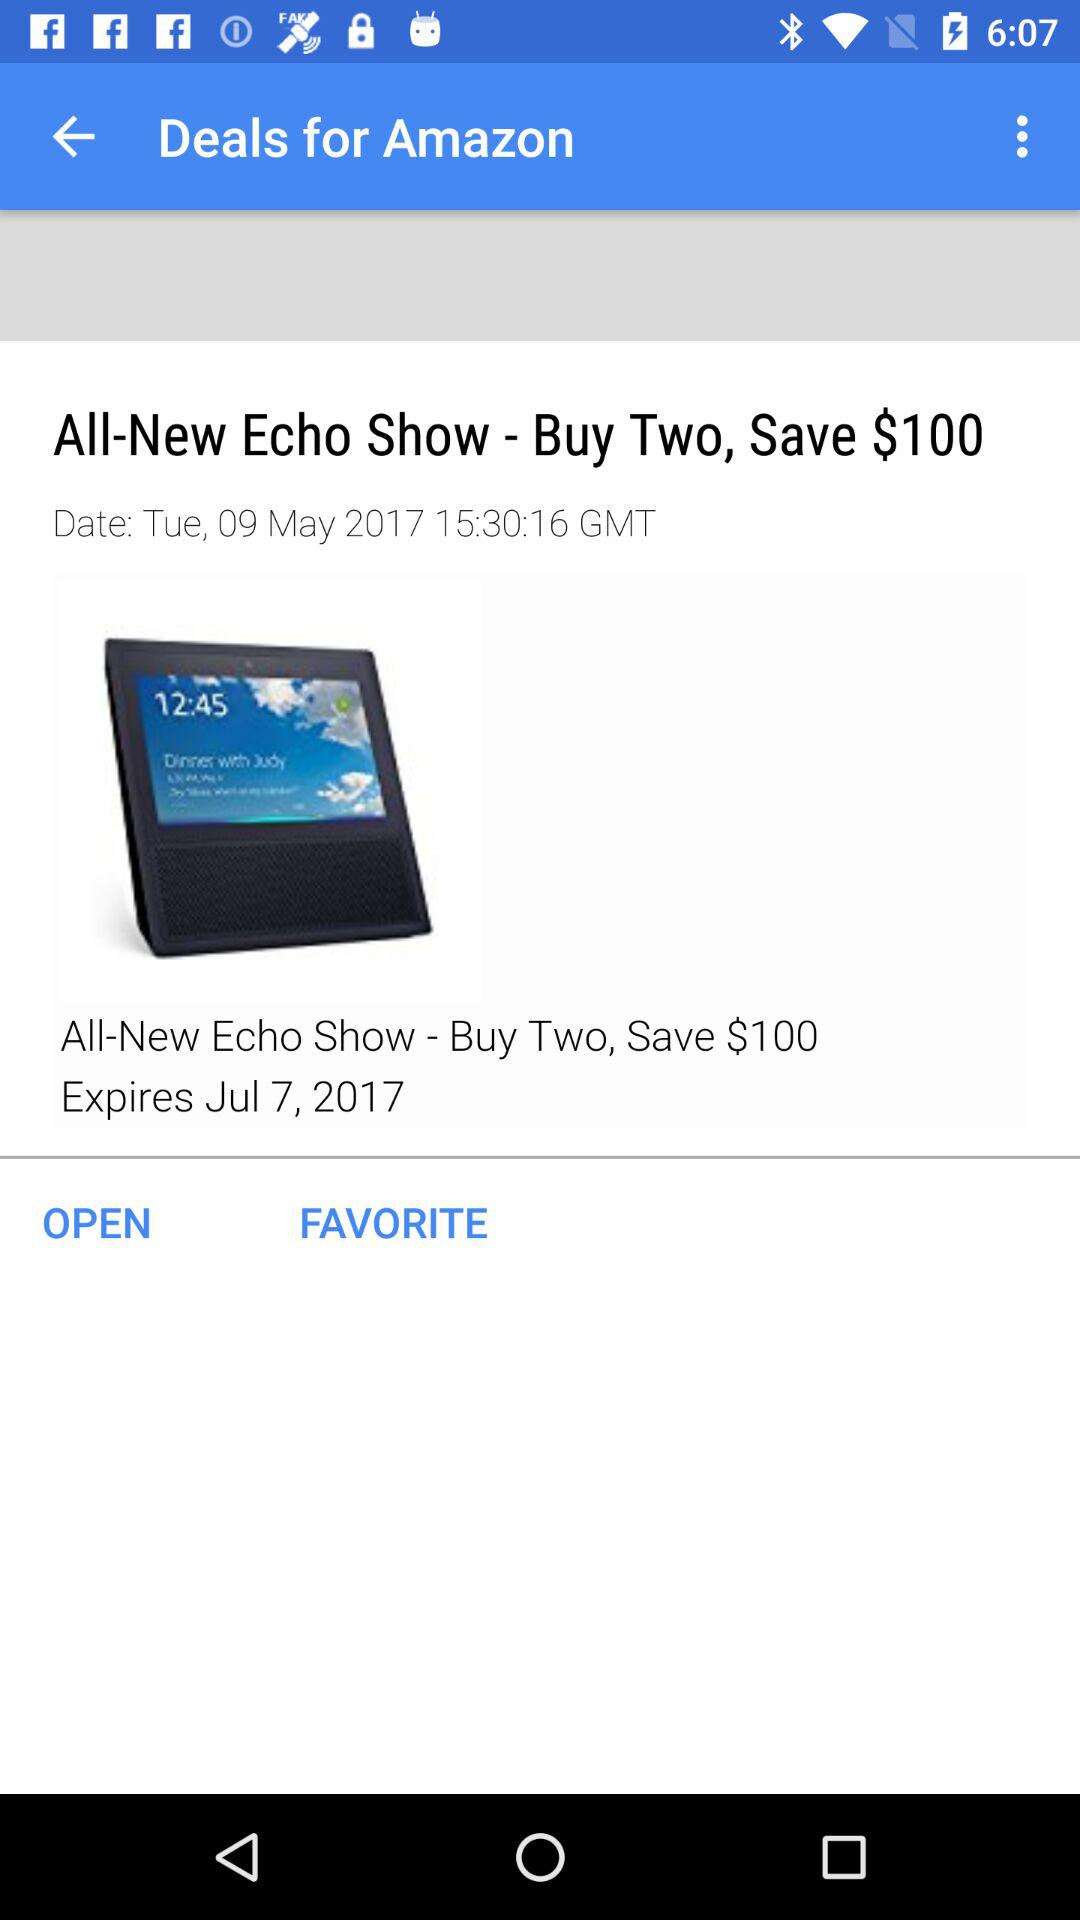What is the day on 09 May 2017? The day is Tuesday. 